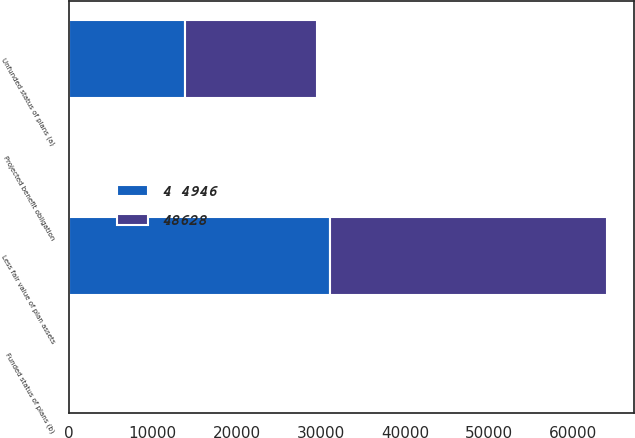<chart> <loc_0><loc_0><loc_500><loc_500><stacked_bar_chart><ecel><fcel>Less fair value of plan assets<fcel>Unfunded status of plans (a)<fcel>Projected benefit obligation<fcel>Funded status of plans (b)<nl><fcel>48628<fcel>32925<fcel>15703<fcel>58<fcel>112<nl><fcel>4 4946<fcel>31091<fcel>13855<fcel>118<fcel>208<nl></chart> 